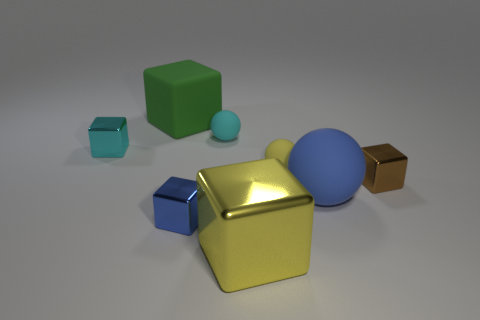What is the color of the large rubber block?
Give a very brief answer. Green. What number of other things are there of the same shape as the tiny brown thing?
Your response must be concise. 4. Are there the same number of yellow spheres to the left of the tiny cyan metallic block and large metallic things that are behind the green block?
Offer a terse response. Yes. What is the material of the brown cube?
Give a very brief answer. Metal. There is a small sphere that is to the right of the large metallic thing; what is its material?
Give a very brief answer. Rubber. Is there anything else that is the same material as the small cyan ball?
Provide a succinct answer. Yes. Are there more big yellow metal blocks that are behind the tiny cyan sphere than tiny yellow blocks?
Ensure brevity in your answer.  No. There is a large matte object in front of the tiny matte object that is on the left side of the yellow metal block; are there any large green rubber cubes to the right of it?
Provide a short and direct response. No. Are there any yellow rubber spheres in front of the large green matte block?
Provide a succinct answer. Yes. How many small matte things have the same color as the big rubber block?
Provide a short and direct response. 0. 